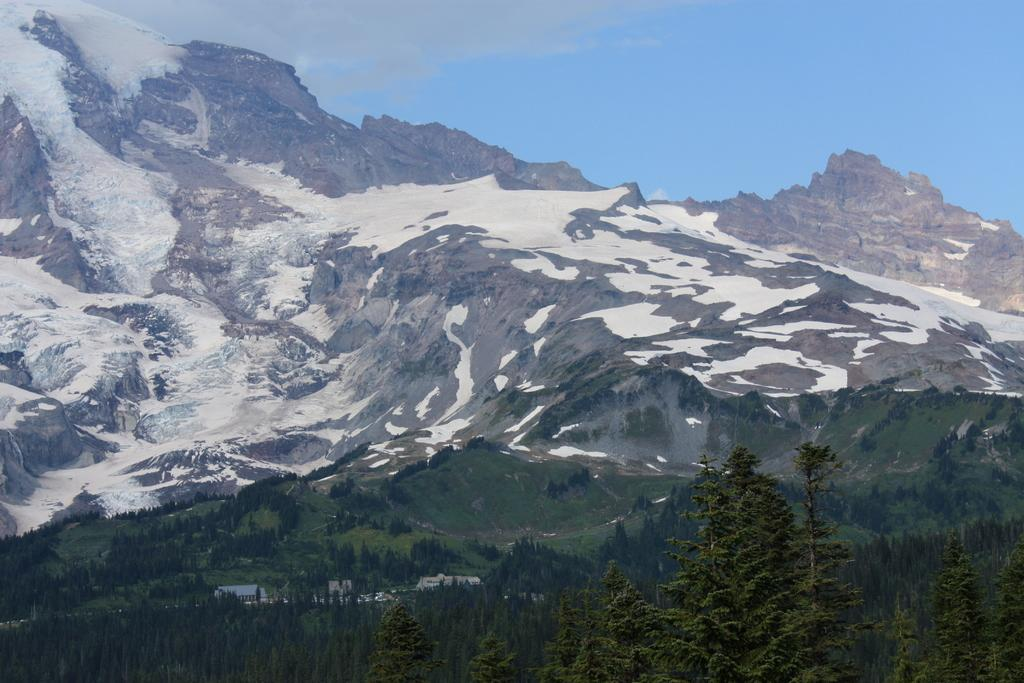What type of natural elements can be seen in the image? There are trees in the image. What type of man-made structures are present in the image? There are buildings in the image. What can be seen in the distance in the image? There are mountains in the background of the image. What is the condition of the mountains in the image? The mountains are covered with snow. What type of silk is being used to create the thought bubbles in the image? There are no thought bubbles or silk present in the image. How many horses can be seen grazing in the image? There are no horses present in the image. 